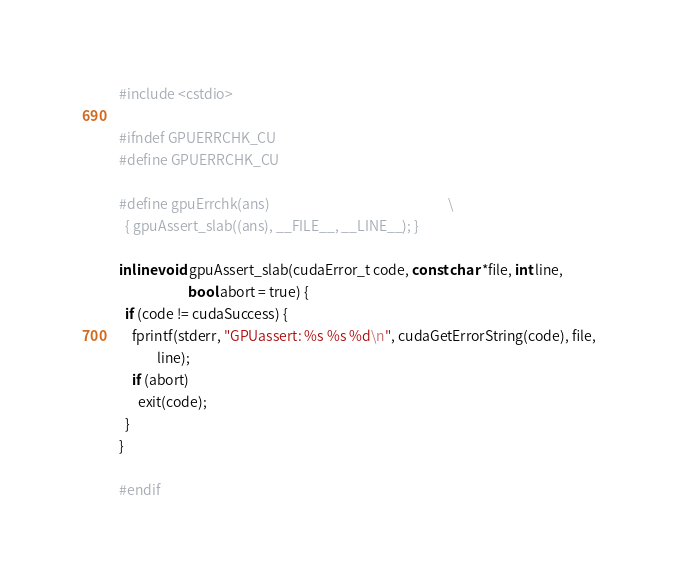Convert code to text. <code><loc_0><loc_0><loc_500><loc_500><_Cuda_>#include <cstdio>

#ifndef GPUERRCHK_CU
#define GPUERRCHK_CU

#define gpuErrchk(ans)                                                         \
  { gpuAssert_slab((ans), __FILE__, __LINE__); }

inline void gpuAssert_slab(cudaError_t code, const char *file, int line,
                      bool abort = true) {
  if (code != cudaSuccess) {
    fprintf(stderr, "GPUassert: %s %s %d\n", cudaGetErrorString(code), file,
            line);
    if (abort)
      exit(code);
  }
}

#endif</code> 